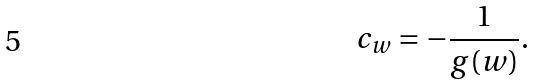<formula> <loc_0><loc_0><loc_500><loc_500>c _ { w } = - \frac { 1 } { g ( w ) } .</formula> 